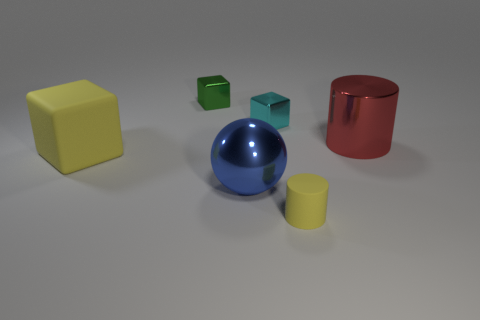Add 1 spheres. How many objects exist? 7 Subtract all cylinders. How many objects are left? 4 Subtract all yellow objects. Subtract all large yellow matte cubes. How many objects are left? 3 Add 3 small objects. How many small objects are left? 6 Add 6 green blocks. How many green blocks exist? 7 Subtract 0 gray cubes. How many objects are left? 6 